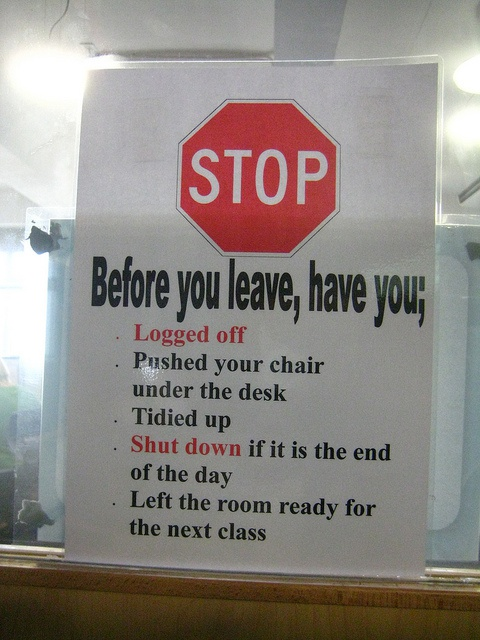Describe the objects in this image and their specific colors. I can see a stop sign in darkgray and brown tones in this image. 